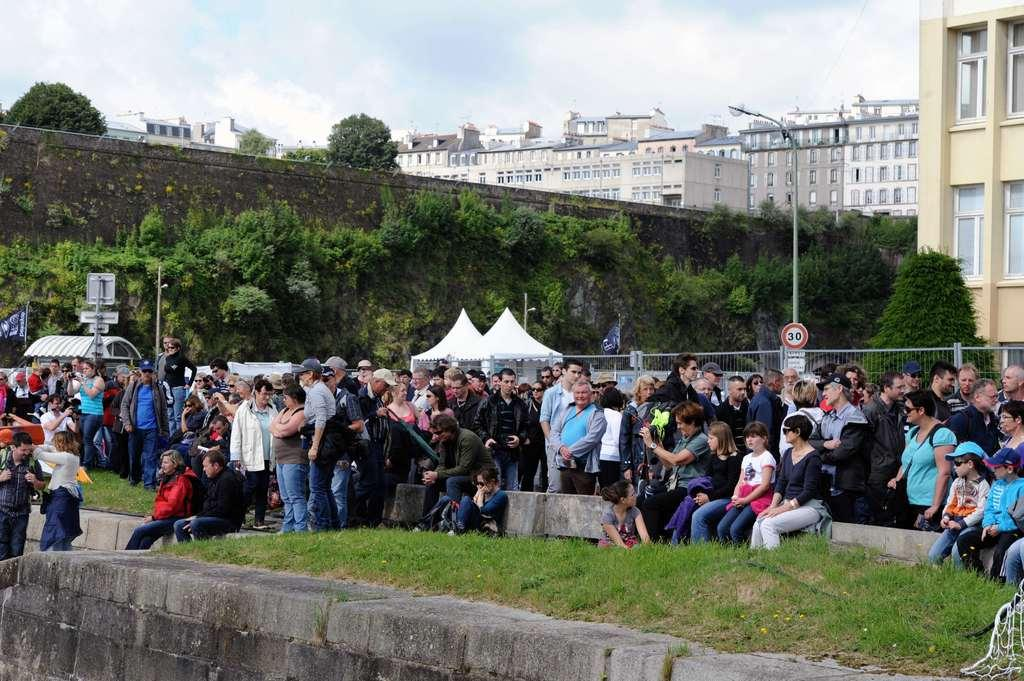What type of structures can be seen in the image? There are buildings in the image. What else can be seen in the image besides buildings? There are trees, tents, people standing, people sitting, and people watching in the image. What are the people in the image doing? Some people are standing, some are sitting, and some are watching in the image. What type of seat can be seen in the image? There is no specific seat mentioned or visible in the image. Can you describe the neck of the person standing in the image? There is no specific person's neck mentioned or visible in the image. 